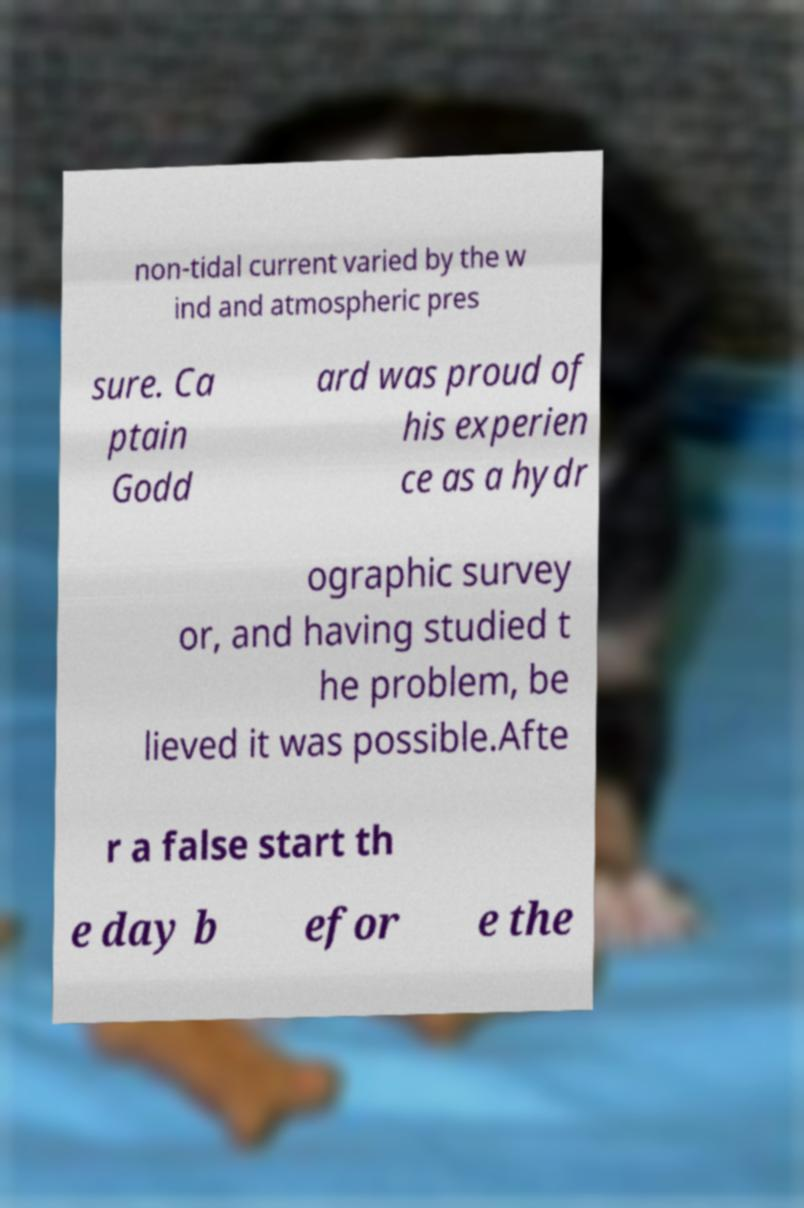I need the written content from this picture converted into text. Can you do that? non-tidal current varied by the w ind and atmospheric pres sure. Ca ptain Godd ard was proud of his experien ce as a hydr ographic survey or, and having studied t he problem, be lieved it was possible.Afte r a false start th e day b efor e the 